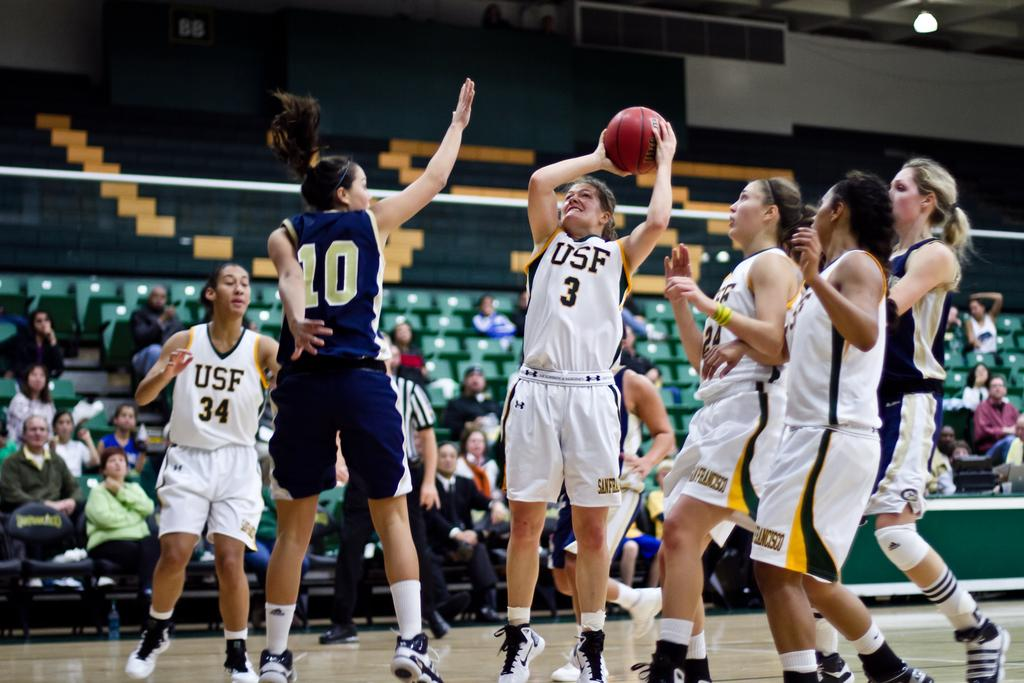What activity are the women in the image engaged in? The women in the image are playing basketball. Where are the women playing basketball? The women are playing basketball in a stadium. Are there any other people present in the image besides the women playing basketball? Yes, there are spectators watching the game in the image. What type of jeans are the basketball players wearing in the image? There is no mention of jeans in the image, as the focus is on the women playing basketball and their attire is not specified. 